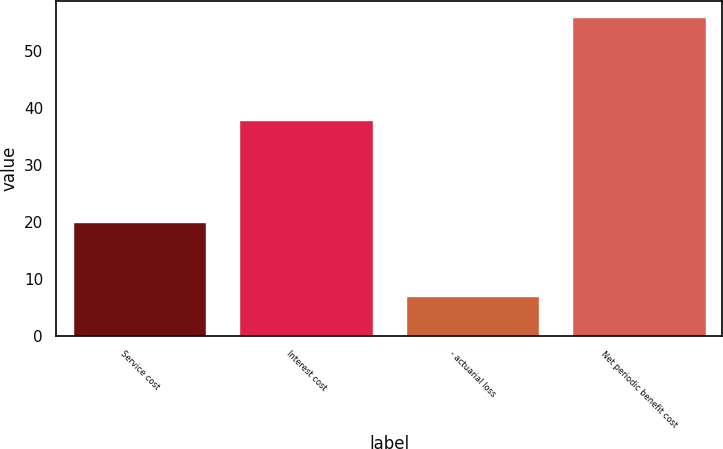<chart> <loc_0><loc_0><loc_500><loc_500><bar_chart><fcel>Service cost<fcel>Interest cost<fcel>- actuarial loss<fcel>Net periodic benefit cost<nl><fcel>20<fcel>38<fcel>7<fcel>56<nl></chart> 